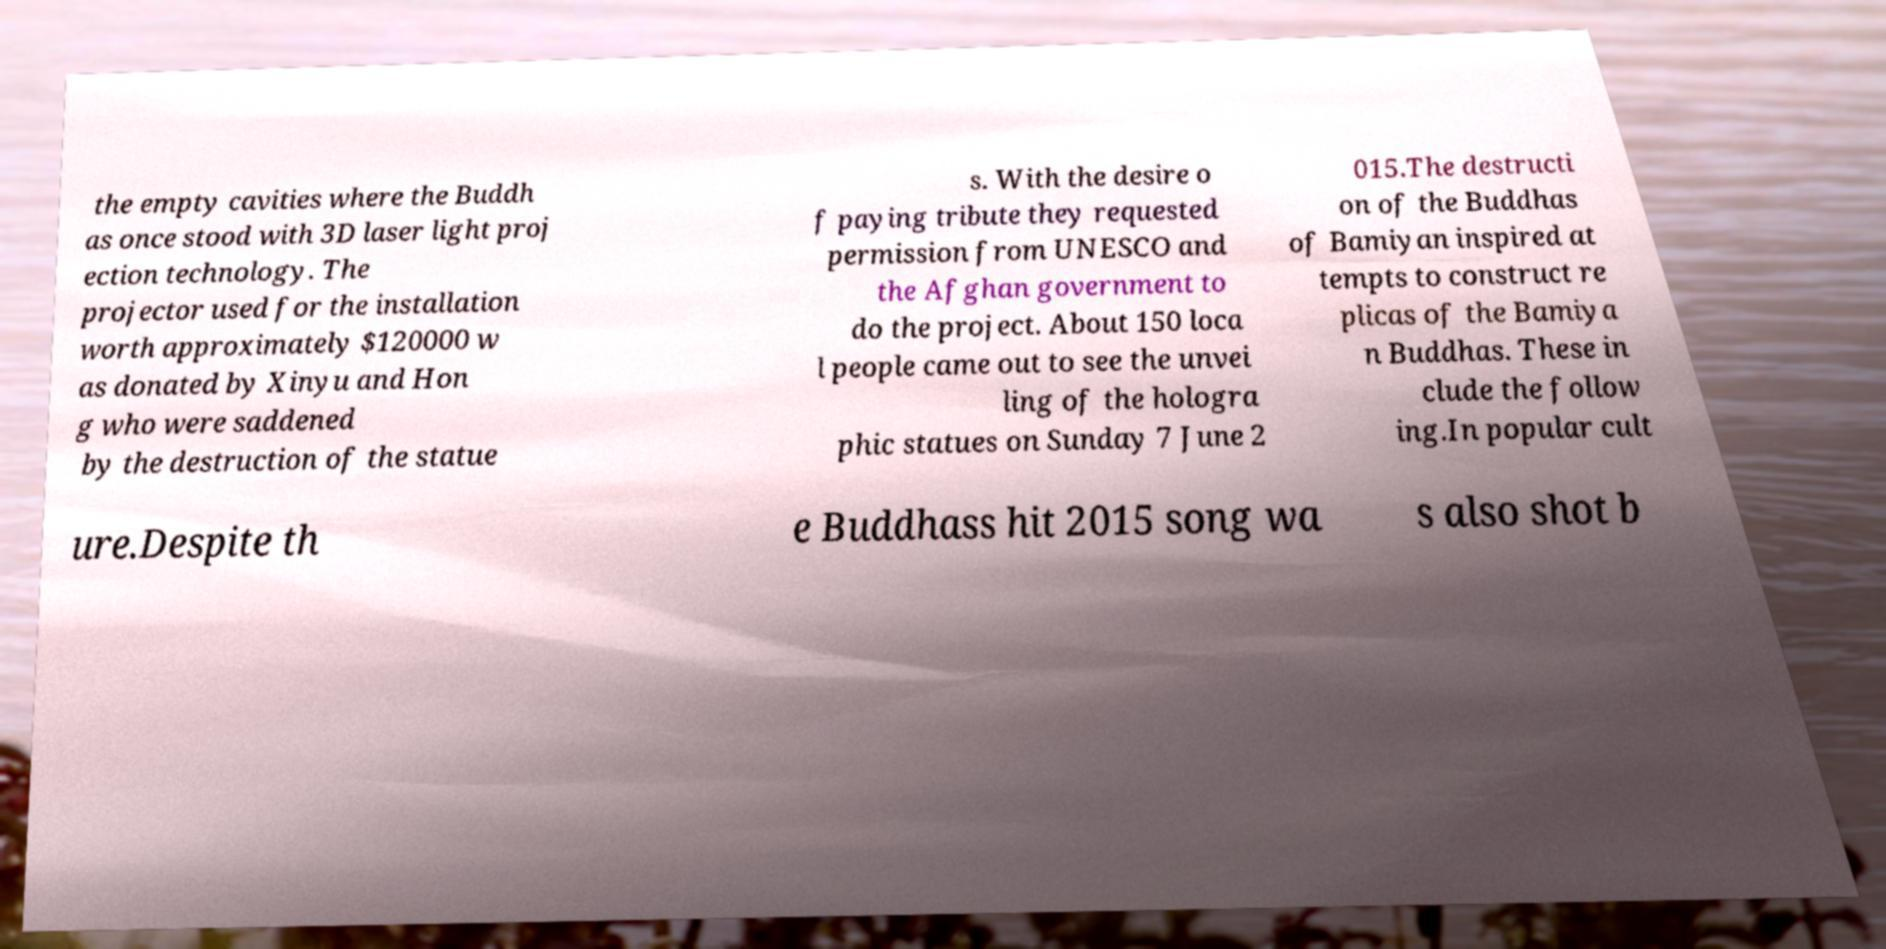For documentation purposes, I need the text within this image transcribed. Could you provide that? the empty cavities where the Buddh as once stood with 3D laser light proj ection technology. The projector used for the installation worth approximately $120000 w as donated by Xinyu and Hon g who were saddened by the destruction of the statue s. With the desire o f paying tribute they requested permission from UNESCO and the Afghan government to do the project. About 150 loca l people came out to see the unvei ling of the hologra phic statues on Sunday 7 June 2 015.The destructi on of the Buddhas of Bamiyan inspired at tempts to construct re plicas of the Bamiya n Buddhas. These in clude the follow ing.In popular cult ure.Despite th e Buddhass hit 2015 song wa s also shot b 